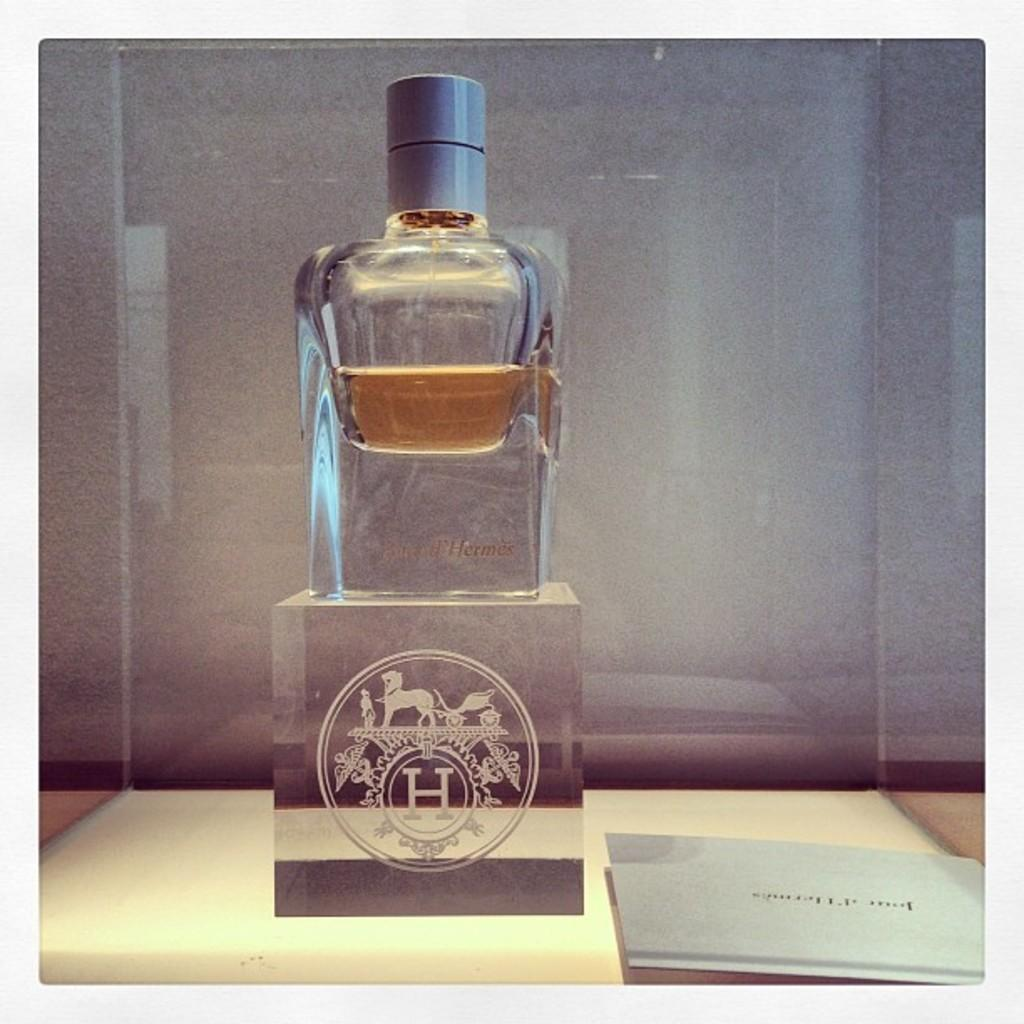<image>
Relay a brief, clear account of the picture shown. A bottle with amber colored liquid in it with a stylized H under it. 